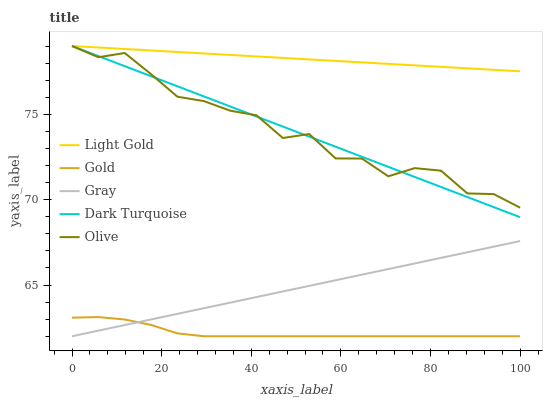Does Gold have the minimum area under the curve?
Answer yes or no. Yes. Does Light Gold have the maximum area under the curve?
Answer yes or no. Yes. Does Gray have the minimum area under the curve?
Answer yes or no. No. Does Gray have the maximum area under the curve?
Answer yes or no. No. Is Light Gold the smoothest?
Answer yes or no. Yes. Is Olive the roughest?
Answer yes or no. Yes. Is Gray the smoothest?
Answer yes or no. No. Is Gray the roughest?
Answer yes or no. No. Does Gray have the lowest value?
Answer yes or no. Yes. Does Light Gold have the lowest value?
Answer yes or no. No. Does Dark Turquoise have the highest value?
Answer yes or no. Yes. Does Gray have the highest value?
Answer yes or no. No. Is Gray less than Light Gold?
Answer yes or no. Yes. Is Light Gold greater than Gray?
Answer yes or no. Yes. Does Olive intersect Light Gold?
Answer yes or no. Yes. Is Olive less than Light Gold?
Answer yes or no. No. Is Olive greater than Light Gold?
Answer yes or no. No. Does Gray intersect Light Gold?
Answer yes or no. No. 